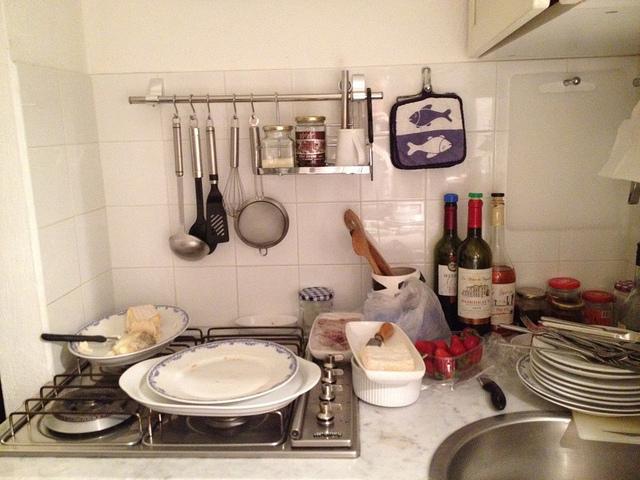What room is this?
Quick response, please. Kitchen. Is the counter messy?
Quick response, please. Yes. Is this a room a group of people would eat a meal in?
Concise answer only. Yes. 